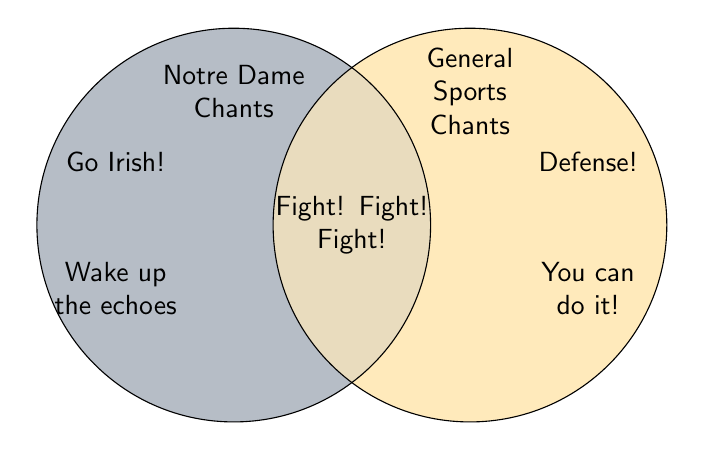What are the two main sections of the Venn Diagram? The visual sections of the Venn Diagram are labeled as "Notre Dame Chants" on the left and "General Sports Chants" on the right, which show the distribution of the chants between these categories.
Answer: Notre Dame Chants and General Sports Chants What chant is located in the overlapping section? The overlapping section is where the two circles intersect and indicates chants that belong to both categories. Since this Venn Diagram has no listed chants in the overlapping section, there are no chants shared between Notre Dame Chants and General Sports Chants.
Answer: None What chant is in the "Notre Dame Chants" section that is not found in general sports? In the left circle labeled "Notre Dame Chants," the "Go Irish!" chant is listed and does not overlap with any general sports chants.
Answer: Go Irish! How many unique chants are in the "General Sports Chants" section? Observing the right circle labeled "General Sports Chants," there are two chants listed which do not overlap with the Notre Dame Chants: "Defense!" and "You can do it!"
Answer: 2 Which section contains the chant "Wake up the echoes"? The "Wake up the echoes" chant is located within the "Notre Dame Chants" section, specifically in the left circle.
Answer: Notre Dame Chants Count the number of chants in each section. How many more chants does the 'Notre Dame Chants' section have compared to 'General Sports Chants'? The "Notre Dame Chants" section contains two chants ("Go Irish!" and "Wake up the echoes"). The "General Sports Chants" section contains two chants ("Defense!" and "You can do it!"). The difference in the number of chants is zero.
Answer: 0 How is the overlapping section visually represented? The overlapping section of the Venn Diagram is a shaded area where the two circles meet. It is created by filling the intersection of both circles with a blended color from the fill colors of each section.
Answer: Shaded overlap of both circles Which chant emphasizes encouragement within the "General Sports Chants"? The chant "You can do it!" in the right circle represents encouragement within the "General Sports Chants" section.
Answer: You can do it! How does the coloring distinguish between Notre Dame Chants and General Sports Chants? The left circle representing "Notre Dame Chants" is filled with a navy shade, and the right circle labeled "General Sports Chants" is filled with a gold shade. This helps distinguish the different categories visually.
Answer: Navy and gold hues 